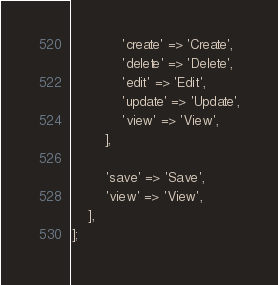Convert code to text. <code><loc_0><loc_0><loc_500><loc_500><_PHP_>            'create' => 'Create',
            'delete' => 'Delete',
            'edit' => 'Edit',
            'update' => 'Update',
            'view' => 'View',
        ],

        'save' => 'Save',
        'view' => 'View',
    ],
];
</code> 